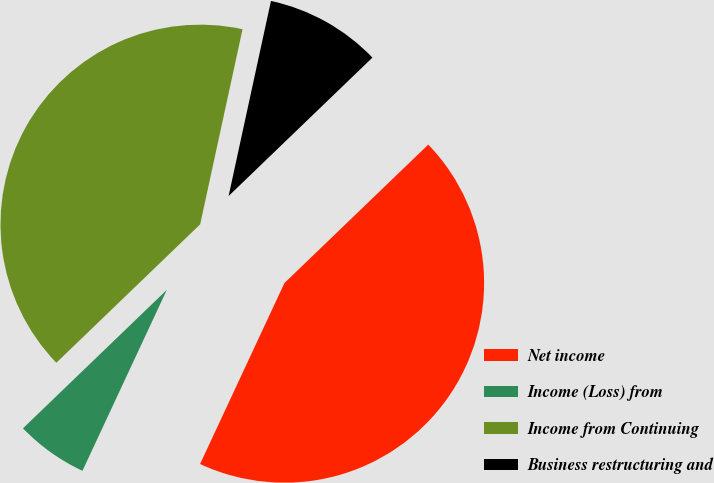Convert chart to OTSL. <chart><loc_0><loc_0><loc_500><loc_500><pie_chart><fcel>Net income<fcel>Income (Loss) from<fcel>Income from Continuing<fcel>Business restructuring and<nl><fcel>44.14%<fcel>5.86%<fcel>40.6%<fcel>9.4%<nl></chart> 